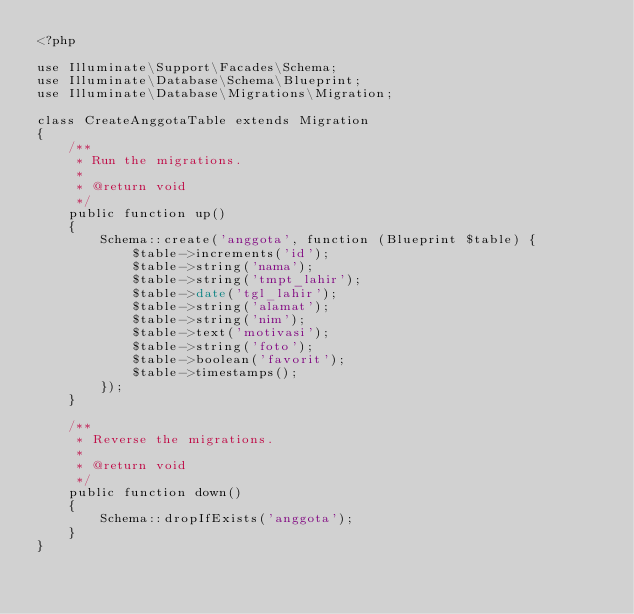Convert code to text. <code><loc_0><loc_0><loc_500><loc_500><_PHP_><?php

use Illuminate\Support\Facades\Schema;
use Illuminate\Database\Schema\Blueprint;
use Illuminate\Database\Migrations\Migration;

class CreateAnggotaTable extends Migration
{
    /**
     * Run the migrations.
     *
     * @return void
     */
    public function up()
    {
        Schema::create('anggota', function (Blueprint $table) {
            $table->increments('id');
            $table->string('nama');
            $table->string('tmpt_lahir');
            $table->date('tgl_lahir');
            $table->string('alamat');
            $table->string('nim');
            $table->text('motivasi');
            $table->string('foto');
            $table->boolean('favorit');
            $table->timestamps();
        });
    }

    /**
     * Reverse the migrations.
     *
     * @return void
     */
    public function down()
    {
        Schema::dropIfExists('anggota');
    }
}
</code> 